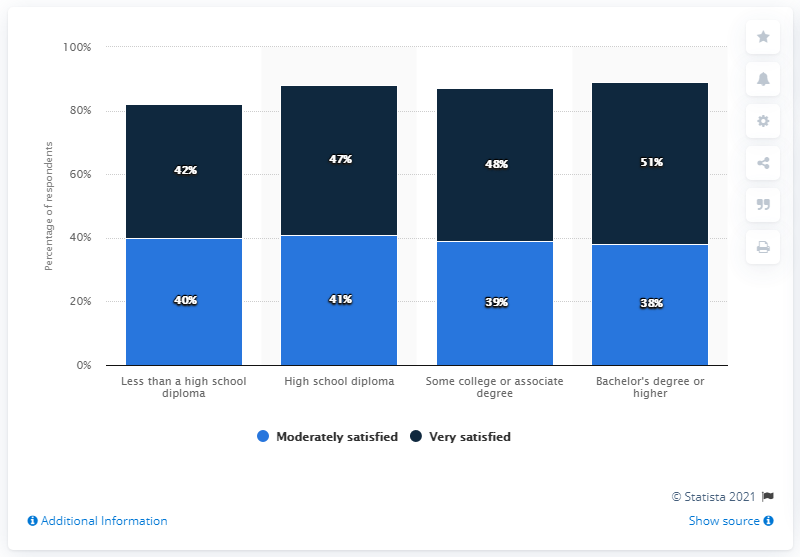List a handful of essential elements in this visual. According to the survey, 47% of people who have a high school diploma are very satisfied with their education. The average score of moderately satisfied people is 39.5. 